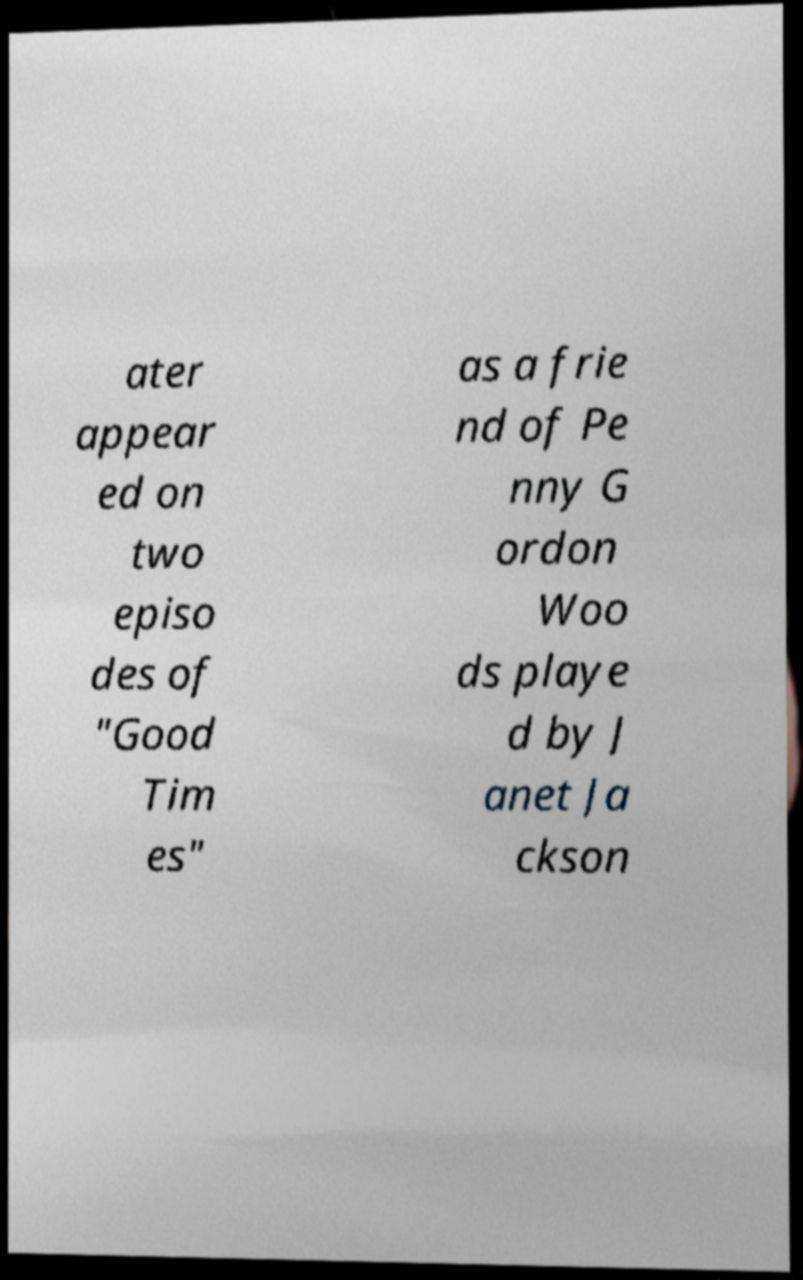For documentation purposes, I need the text within this image transcribed. Could you provide that? ater appear ed on two episo des of "Good Tim es" as a frie nd of Pe nny G ordon Woo ds playe d by J anet Ja ckson 